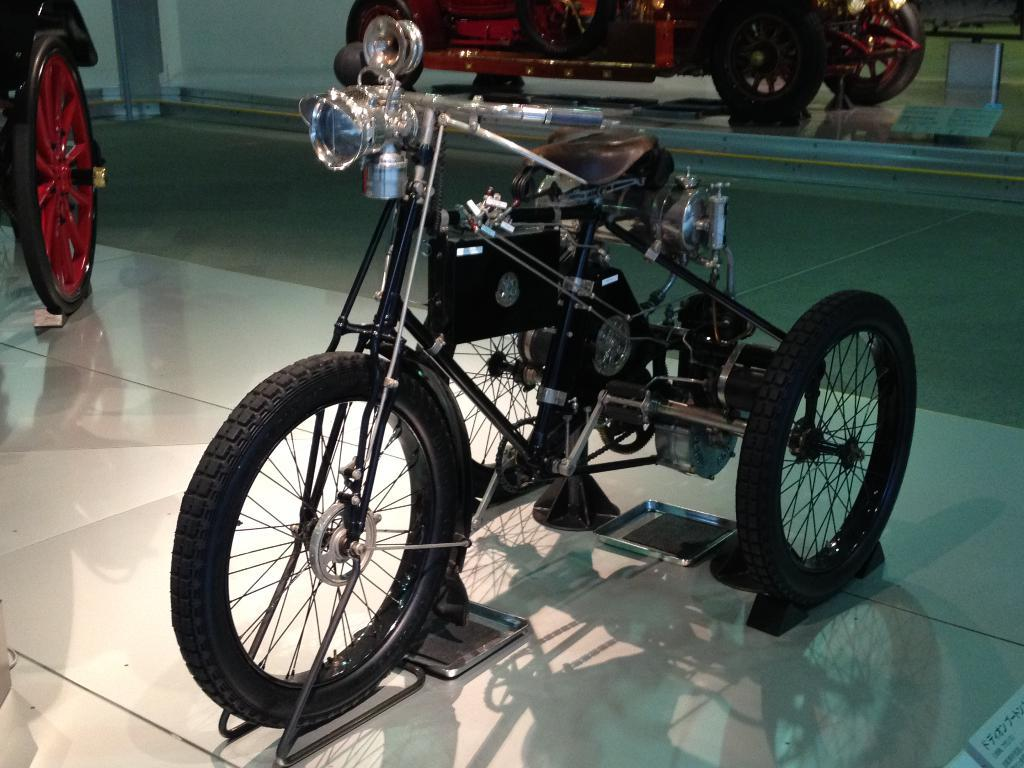What is the main subject in the center of the image? There is a vehicle in the center of the image. Can you describe the other vehicle visible in the image? There is another four-wheeler vehicle visible at the top of the image. What type of medical advice can be heard from the doctor in the image? There is no doctor present in the image, so no medical advice can be heard. 